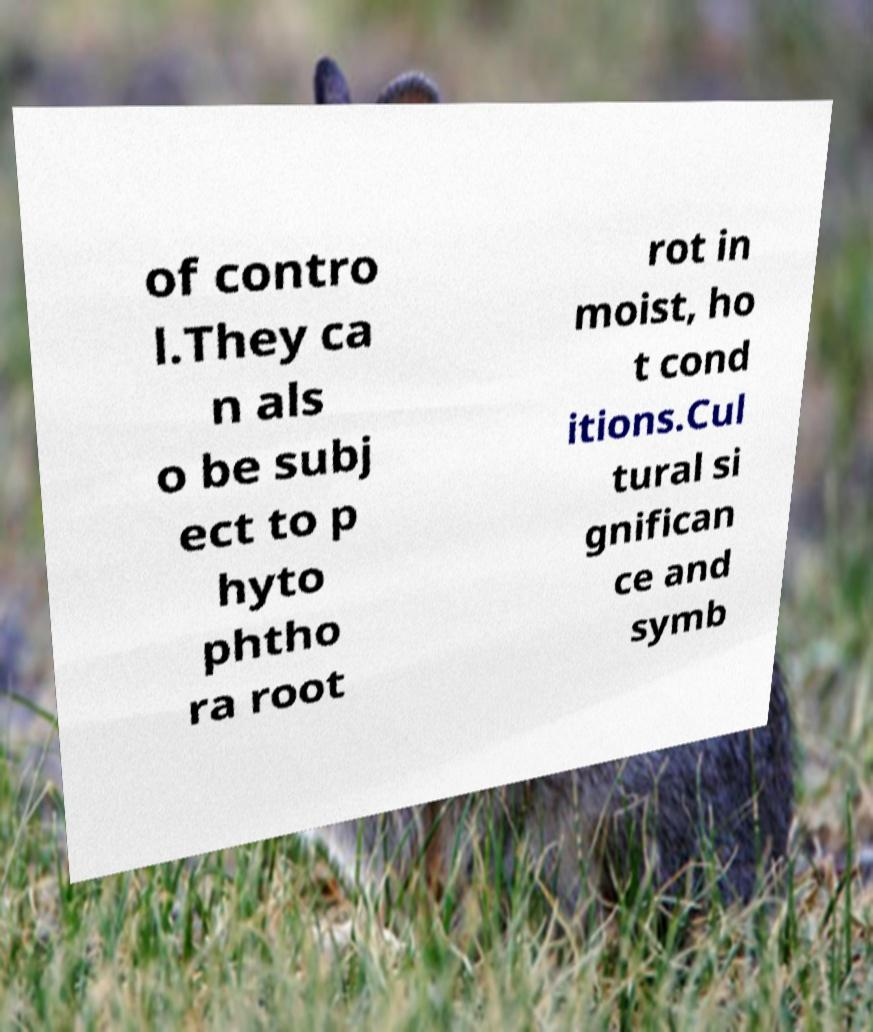Could you extract and type out the text from this image? of contro l.They ca n als o be subj ect to p hyto phtho ra root rot in moist, ho t cond itions.Cul tural si gnifican ce and symb 